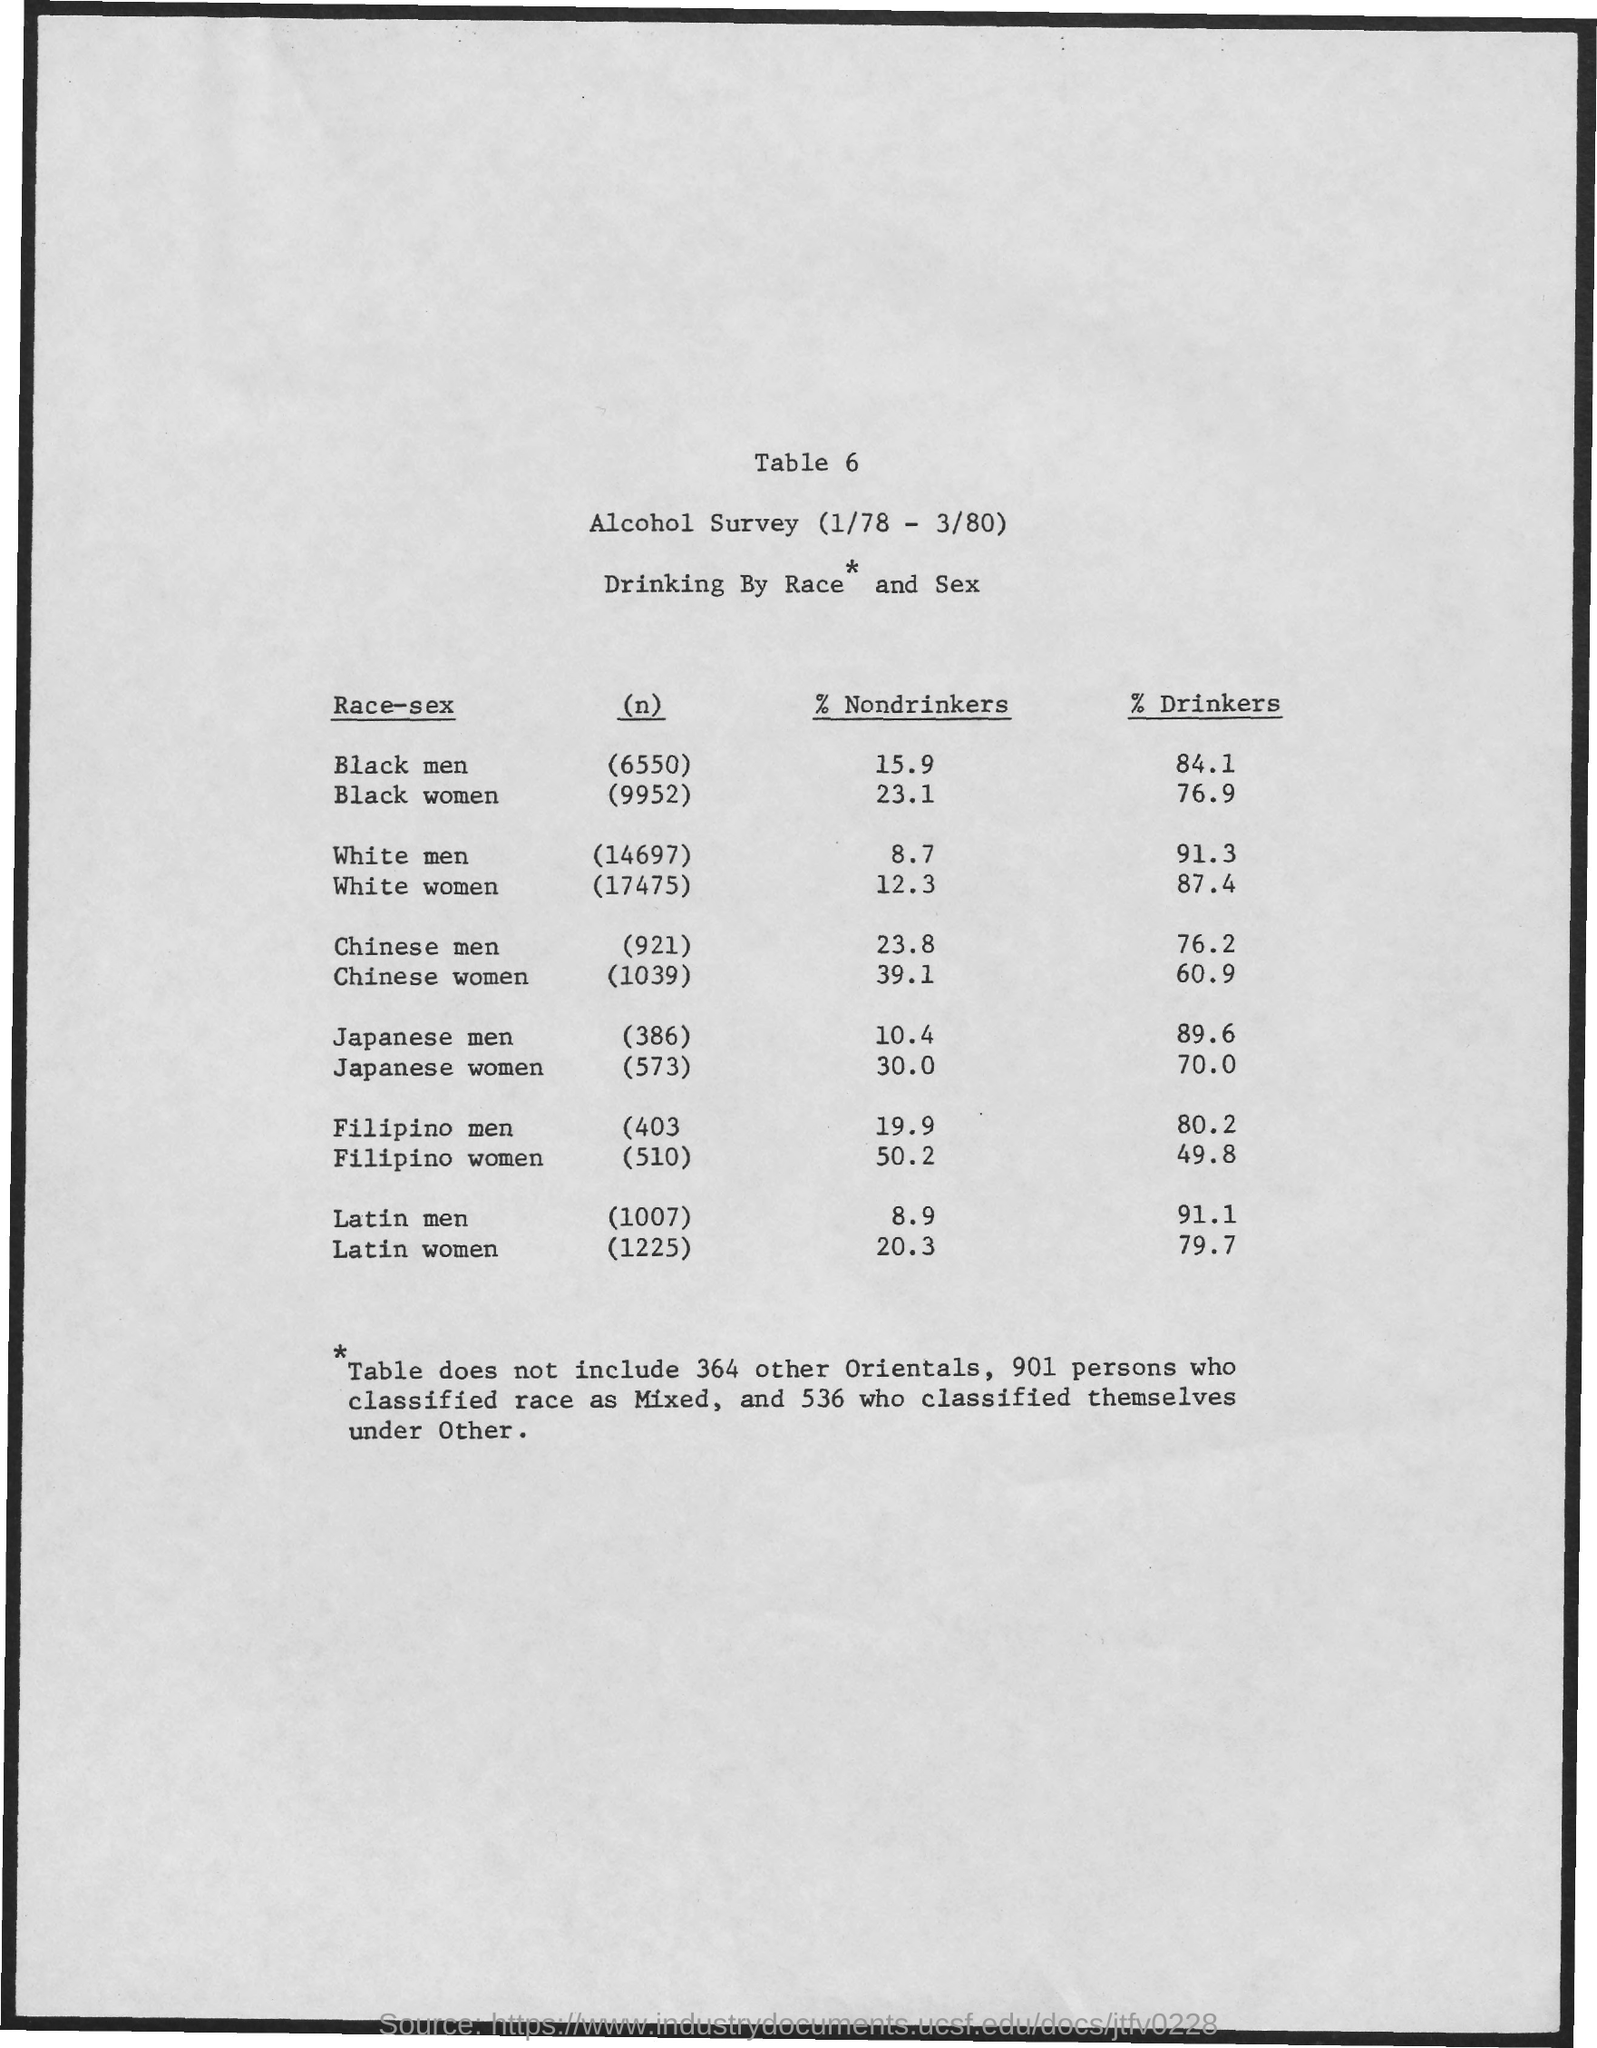What is the table number?
Offer a terse response. 6. What is the number of black men?
Keep it short and to the point. 6550. What is the percentage of nondrinkers in black men?
Your answer should be compact. 15.9. What is the number of white women?
Your answer should be compact. 17475. What is the percentage of drinkers in white women?
Your answer should be very brief. 87.4. What is the number of Latin Women?
Keep it short and to the point. 1225. The percentage of nondrinkers is highest in which race-sex?
Provide a short and direct response. Filipino women. The percentage of nondrinkers is lowest in which race-sex?
Your answer should be compact. White men. The percentage of drinkers is highest in which race-sex?
Provide a succinct answer. White men. The percentage of drinkers is lowest in which race-sex?
Offer a terse response. Filipino women. 